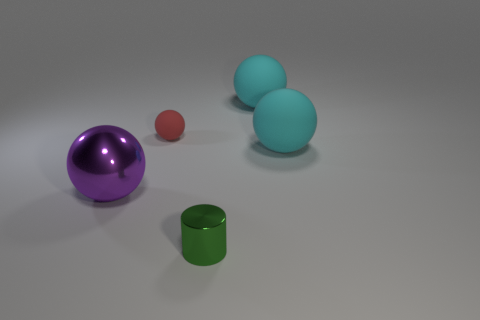Can you tell me about the lighting in the scene? The lighting in the scene is soft and diffused, casting gentle shadows and highlighting the shapes of the objects. It seems to be coming from above but doesn't create a harsh glare on any of the items. 